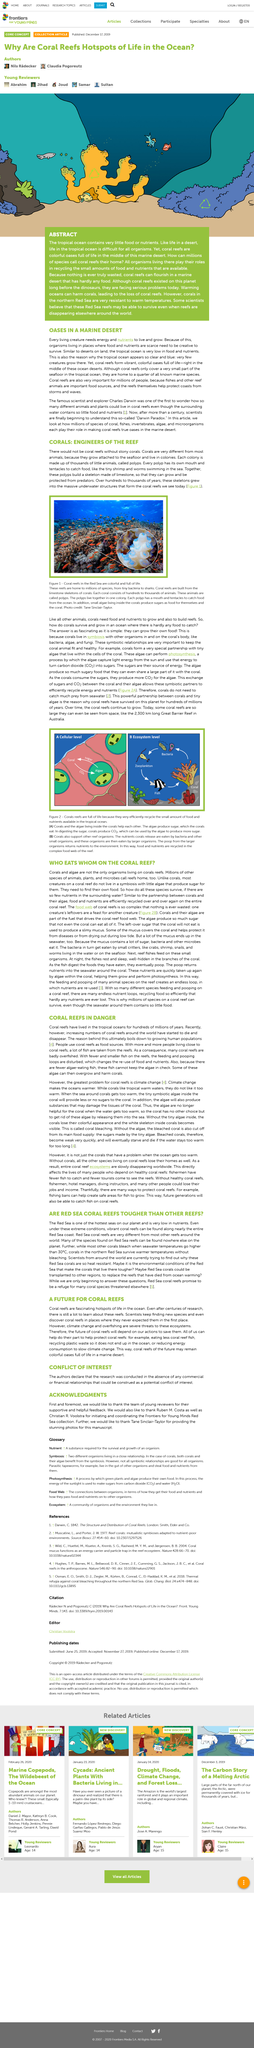Draw attention to some important aspects in this diagram. Coral reefs have lived in tropical oceans for hundreds of millions of years. Pol The dying of coral reefs is due to the growing human population, which leads to increased pollution, ocean acidification, and overfishing. Stony corals are essential to the survival of reefs and cannot be omitted from their ecosystem. The type of reef discussed throughout this article is a coral reef. 